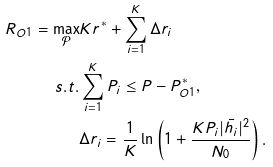<formula> <loc_0><loc_0><loc_500><loc_500>R _ { O 1 } = \max _ { \mathcal { P } } & K r ^ { * } + \sum _ { i = 1 } ^ { K } \Delta r _ { i } \\ s . t . & \sum _ { i = 1 } ^ { K } P _ { i } \leq P - P _ { O 1 } ^ { * } , \\ & \Delta r _ { i } = \frac { 1 } { K } \ln \left ( 1 + \frac { K P _ { i } | \bar { h _ { i } } | ^ { 2 } } { N _ { 0 } } \right ) .</formula> 